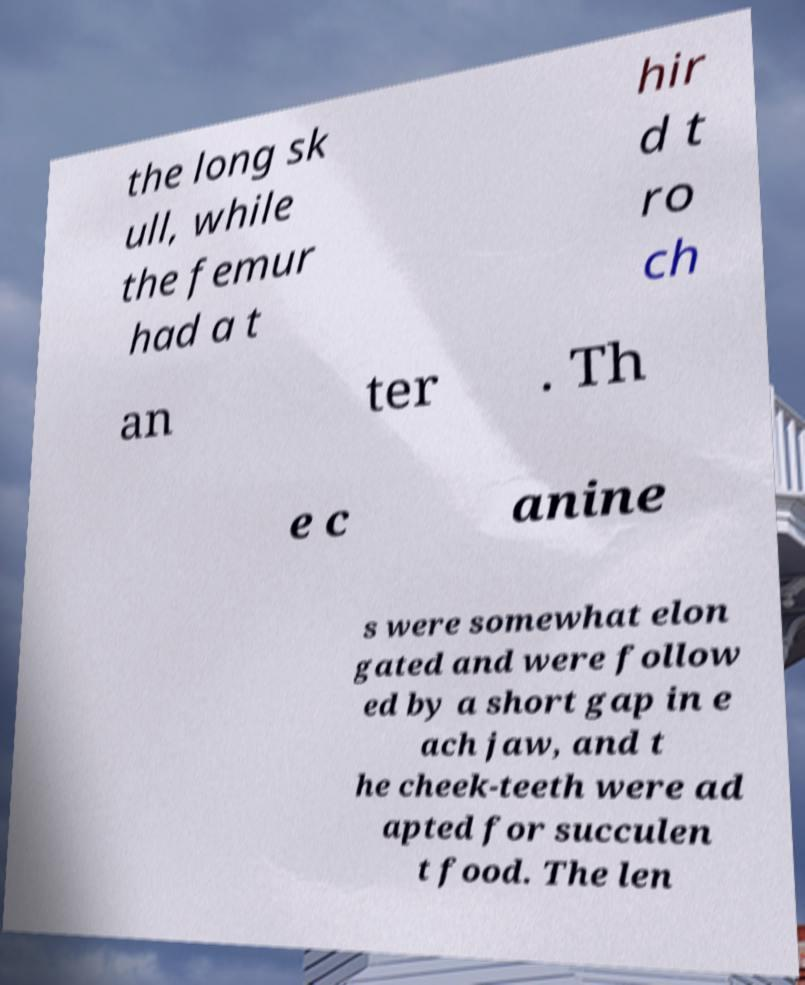There's text embedded in this image that I need extracted. Can you transcribe it verbatim? the long sk ull, while the femur had a t hir d t ro ch an ter . Th e c anine s were somewhat elon gated and were follow ed by a short gap in e ach jaw, and t he cheek-teeth were ad apted for succulen t food. The len 